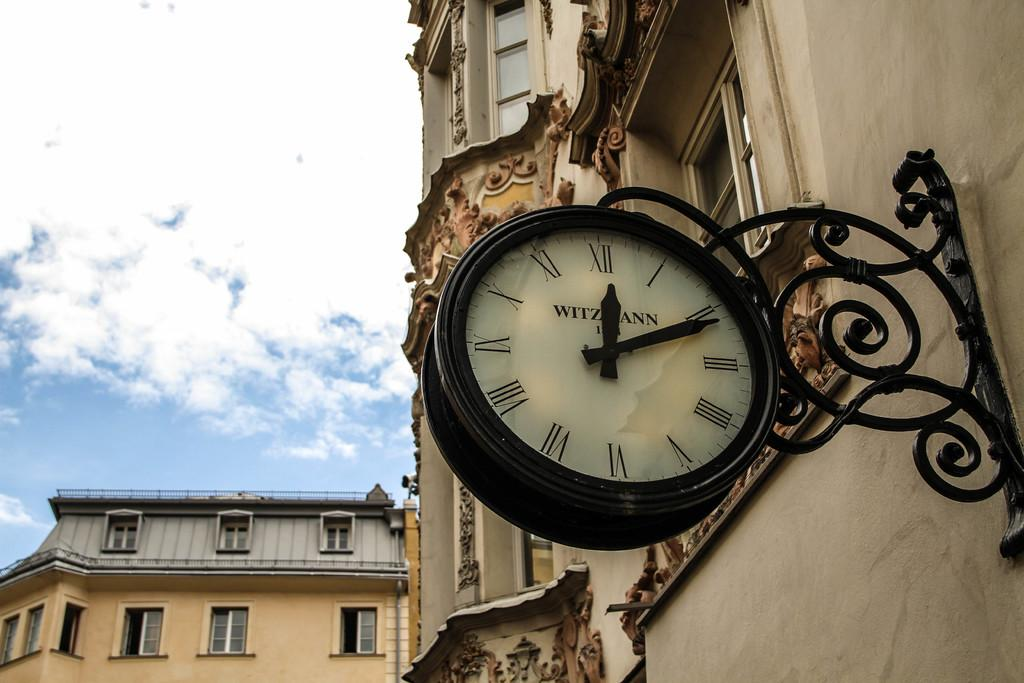<image>
Write a terse but informative summary of the picture. A Witzmann clock hangs from the side of a building. 